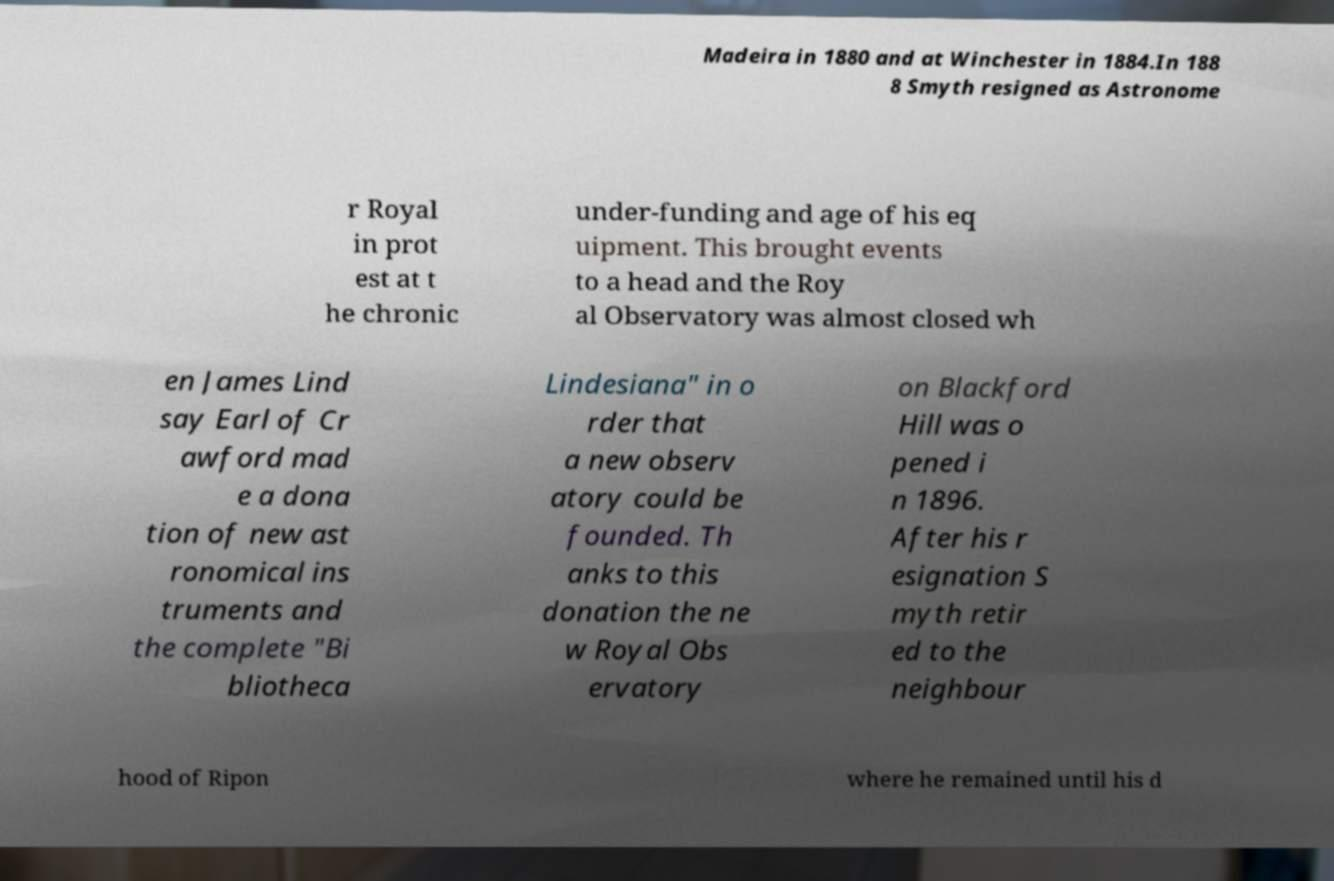Could you extract and type out the text from this image? Madeira in 1880 and at Winchester in 1884.In 188 8 Smyth resigned as Astronome r Royal in prot est at t he chronic under-funding and age of his eq uipment. This brought events to a head and the Roy al Observatory was almost closed wh en James Lind say Earl of Cr awford mad e a dona tion of new ast ronomical ins truments and the complete "Bi bliotheca Lindesiana" in o rder that a new observ atory could be founded. Th anks to this donation the ne w Royal Obs ervatory on Blackford Hill was o pened i n 1896. After his r esignation S myth retir ed to the neighbour hood of Ripon where he remained until his d 